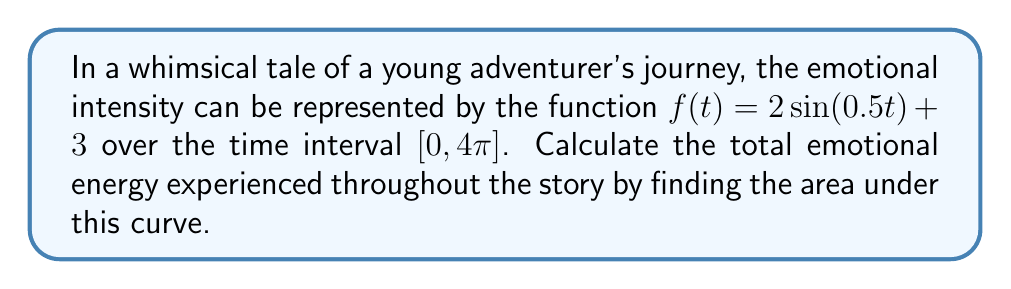Teach me how to tackle this problem. To solve this problem, we need to integrate the given function over the specified interval. Let's break it down step-by-step:

1) The function representing emotional intensity is:
   $f(t) = 2\sin(0.5t) + 3$

2) We need to find the definite integral of this function from $0$ to $4\pi$:
   $$\int_0^{4\pi} (2\sin(0.5t) + 3) dt$$

3) Let's separate this into two integrals:
   $$\int_0^{4\pi} 2\sin(0.5t) dt + \int_0^{4\pi} 3 dt$$

4) For the first integral, we can use the substitution method:
   Let $u = 0.5t$, then $du = 0.5dt$ or $dt = 2du$
   When $t = 0$, $u = 0$; when $t = 4\pi$, $u = 2\pi$

   $$2\int_0^{2\pi} \sin(u) \cdot 2du = 4\int_0^{2\pi} \sin(u) du = 4[-\cos(u)]_0^{2\pi} = 4[-\cos(2\pi) + \cos(0)] = 0$$

5) For the second integral:
   $$\int_0^{4\pi} 3 dt = 3t|_0^{4\pi} = 3(4\pi) - 3(0) = 12\pi$$

6) Adding the results from steps 4 and 5:
   $0 + 12\pi = 12\pi$

Therefore, the total emotional energy experienced throughout the story is $12\pi$ units.
Answer: $12\pi$ 